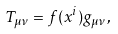Convert formula to latex. <formula><loc_0><loc_0><loc_500><loc_500>T _ { \mu \nu } = f ( x ^ { i } ) g _ { \mu \nu } ,</formula> 